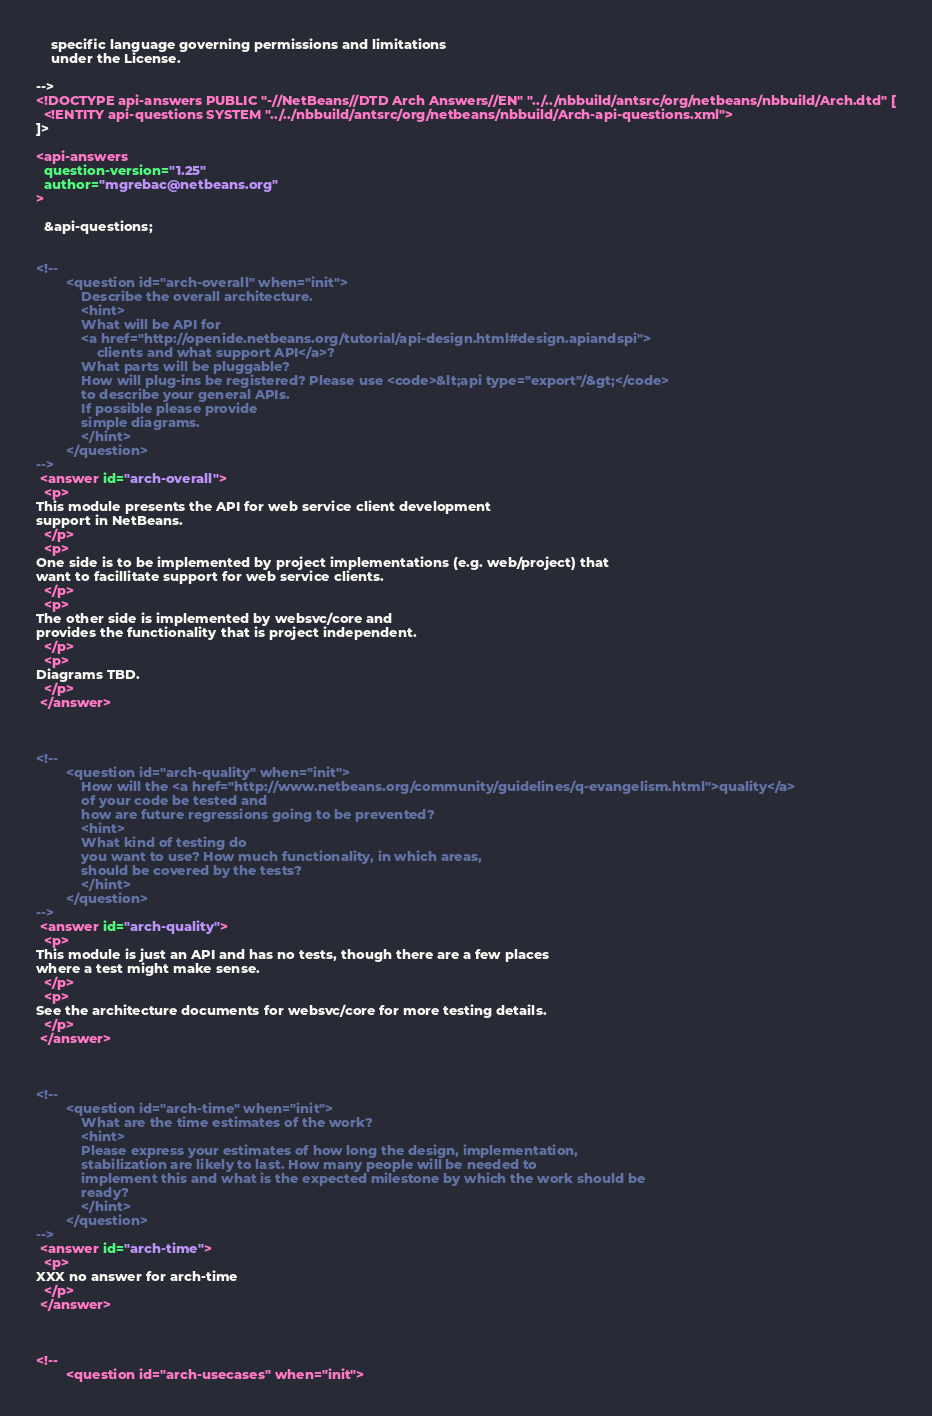<code> <loc_0><loc_0><loc_500><loc_500><_XML_>    specific language governing permissions and limitations
    under the License.

-->
<!DOCTYPE api-answers PUBLIC "-//NetBeans//DTD Arch Answers//EN" "../../nbbuild/antsrc/org/netbeans/nbbuild/Arch.dtd" [
  <!ENTITY api-questions SYSTEM "../../nbbuild/antsrc/org/netbeans/nbbuild/Arch-api-questions.xml">
]>

<api-answers
  question-version="1.25"
  author="mgrebac@netbeans.org"
>

  &api-questions;


<!--
        <question id="arch-overall" when="init">
            Describe the overall architecture.
            <hint>
            What will be API for
            <a href="http://openide.netbeans.org/tutorial/api-design.html#design.apiandspi">
                clients and what support API</a>? 
            What parts will be pluggable?
            How will plug-ins be registered? Please use <code>&lt;api type="export"/&gt;</code>
            to describe your general APIs.
            If possible please provide 
            simple diagrams. 
            </hint>
        </question>
-->
 <answer id="arch-overall">
  <p>
This module presents the API for web service client development
support in NetBeans.
  </p>
  <p>
One side is to be implemented by project implementations (e.g. web/project) that
want to facillitate support for web service clients.
  </p>
  <p>
The other side is implemented by websvc/core and
provides the functionality that is project independent.
  </p>
  <p>
Diagrams TBD.
  </p>
 </answer>



<!--
        <question id="arch-quality" when="init">
            How will the <a href="http://www.netbeans.org/community/guidelines/q-evangelism.html">quality</a>
            of your code be tested and 
            how are future regressions going to be prevented?
            <hint>
            What kind of testing do
            you want to use? How much functionality, in which areas,
            should be covered by the tests? 
            </hint>
        </question>
-->
 <answer id="arch-quality">
  <p>
This module is just an API and has no tests, though there are a few places
where a test might make sense.
  </p>
  <p>   
See the architecture documents for websvc/core for more testing details.
  </p>
 </answer>



<!--
        <question id="arch-time" when="init">
            What are the time estimates of the work?
            <hint>
            Please express your estimates of how long the design, implementation,
            stabilization are likely to last. How many people will be needed to
            implement this and what is the expected milestone by which the work should be 
            ready?
            </hint>
        </question>
-->
 <answer id="arch-time">
  <p>
XXX no answer for arch-time
  </p>
 </answer>



<!--
        <question id="arch-usecases" when="init"></code> 